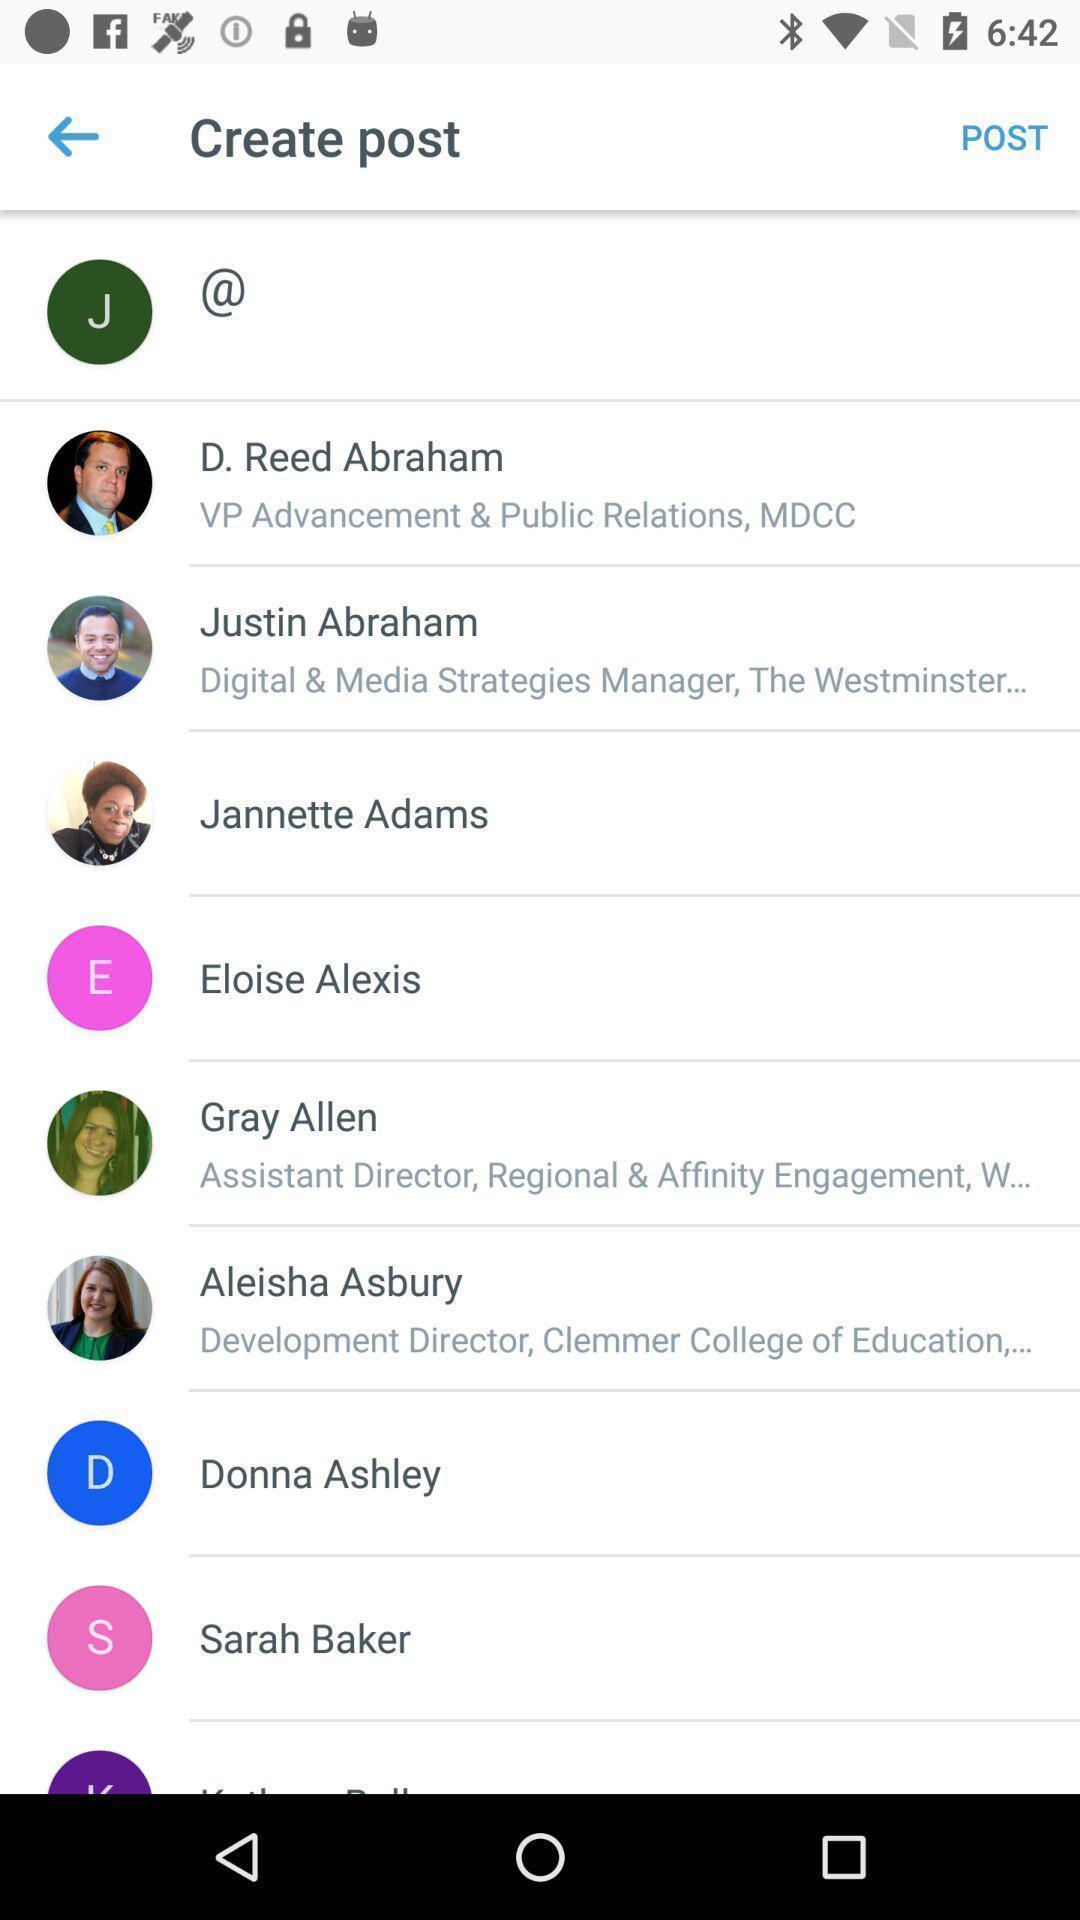Describe the key features of this screenshot. Page for creating a post of social app. 